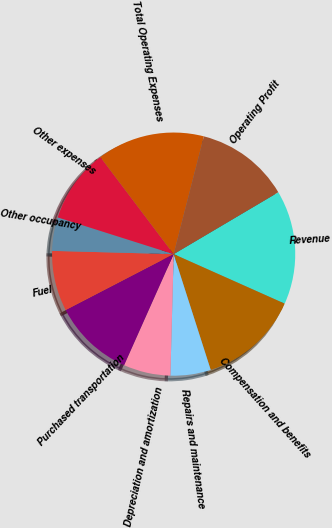Convert chart to OTSL. <chart><loc_0><loc_0><loc_500><loc_500><pie_chart><fcel>Revenue<fcel>Compensation and benefits<fcel>Repairs and maintenance<fcel>Depreciation and amortization<fcel>Purchased transportation<fcel>Fuel<fcel>Other occupancy<fcel>Other expenses<fcel>Total Operating Expenses<fcel>Operating Profit<nl><fcel>15.18%<fcel>13.39%<fcel>5.36%<fcel>6.25%<fcel>10.71%<fcel>8.04%<fcel>4.46%<fcel>9.82%<fcel>14.29%<fcel>12.5%<nl></chart> 